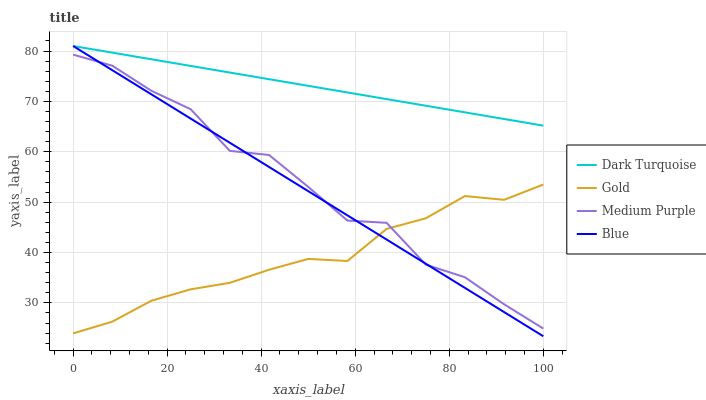Does Gold have the minimum area under the curve?
Answer yes or no. Yes. Does Dark Turquoise have the maximum area under the curve?
Answer yes or no. Yes. Does Dark Turquoise have the minimum area under the curve?
Answer yes or no. No. Does Gold have the maximum area under the curve?
Answer yes or no. No. Is Dark Turquoise the smoothest?
Answer yes or no. Yes. Is Medium Purple the roughest?
Answer yes or no. Yes. Is Gold the smoothest?
Answer yes or no. No. Is Gold the roughest?
Answer yes or no. No. Does Blue have the lowest value?
Answer yes or no. Yes. Does Gold have the lowest value?
Answer yes or no. No. Does Blue have the highest value?
Answer yes or no. Yes. Does Gold have the highest value?
Answer yes or no. No. Is Gold less than Dark Turquoise?
Answer yes or no. Yes. Is Dark Turquoise greater than Medium Purple?
Answer yes or no. Yes. Does Dark Turquoise intersect Blue?
Answer yes or no. Yes. Is Dark Turquoise less than Blue?
Answer yes or no. No. Is Dark Turquoise greater than Blue?
Answer yes or no. No. Does Gold intersect Dark Turquoise?
Answer yes or no. No. 